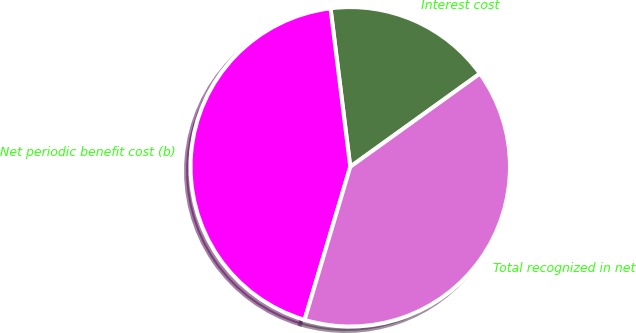<chart> <loc_0><loc_0><loc_500><loc_500><pie_chart><fcel>Interest cost<fcel>Net periodic benefit cost (b)<fcel>Total recognized in net<nl><fcel>17.05%<fcel>43.41%<fcel>39.53%<nl></chart> 